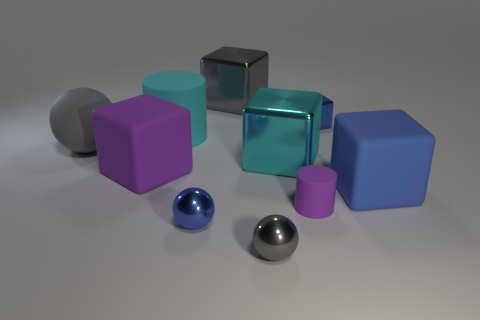Are there any small blue metal objects of the same shape as the large blue matte thing?
Make the answer very short. Yes. There is a matte cube that is right of the small purple thing; does it have the same color as the tiny shiny cube?
Offer a terse response. Yes. The gray object on the left side of the big matte cube on the left side of the purple cylinder is what shape?
Your answer should be very brief. Sphere. Are there any shiny cubes that have the same size as the purple rubber cylinder?
Your answer should be very brief. Yes. Are there fewer yellow shiny blocks than small blue metallic things?
Your answer should be compact. Yes. What shape is the tiny blue thing in front of the large rubber object that is in front of the purple rubber thing behind the big blue rubber thing?
Your answer should be compact. Sphere. How many things are small blue objects in front of the tiny purple rubber object or large matte blocks to the left of the big blue rubber object?
Keep it short and to the point. 2. There is a big cyan cube; are there any big objects to the right of it?
Offer a terse response. Yes. How many things are either small blue shiny objects in front of the large cylinder or gray cubes?
Your answer should be very brief. 2. What number of red things are either matte things or rubber cylinders?
Ensure brevity in your answer.  0. 